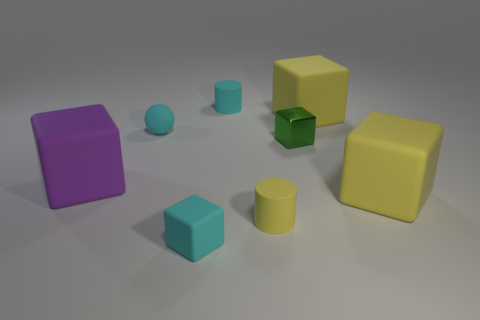Does the big purple object have the same material as the cyan block?
Your response must be concise. Yes. How many brown objects are either small balls or matte cylinders?
Give a very brief answer. 0. Is the number of tiny cyan rubber things that are behind the rubber sphere greater than the number of blue metallic blocks?
Ensure brevity in your answer.  Yes. Are there any rubber cylinders that have the same color as the ball?
Keep it short and to the point. Yes. The purple object has what size?
Keep it short and to the point. Large. Is the color of the shiny block the same as the small ball?
Give a very brief answer. No. How many things are either tiny cyan matte things or cyan rubber things that are on the right side of the cyan cube?
Give a very brief answer. 3. There is a yellow matte cylinder that is in front of the yellow block in front of the tiny ball; what number of rubber blocks are in front of it?
Provide a succinct answer. 1. What is the material of the cube that is the same color as the tiny rubber ball?
Keep it short and to the point. Rubber. How many cyan rubber balls are there?
Your response must be concise. 1. 